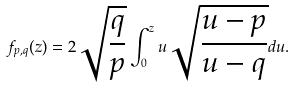Convert formula to latex. <formula><loc_0><loc_0><loc_500><loc_500>f _ { p , q } ( z ) = 2 \sqrt { \frac { q } { p } } \int _ { 0 } ^ { z } u \sqrt { \frac { u - p } { u - q } } d u .</formula> 